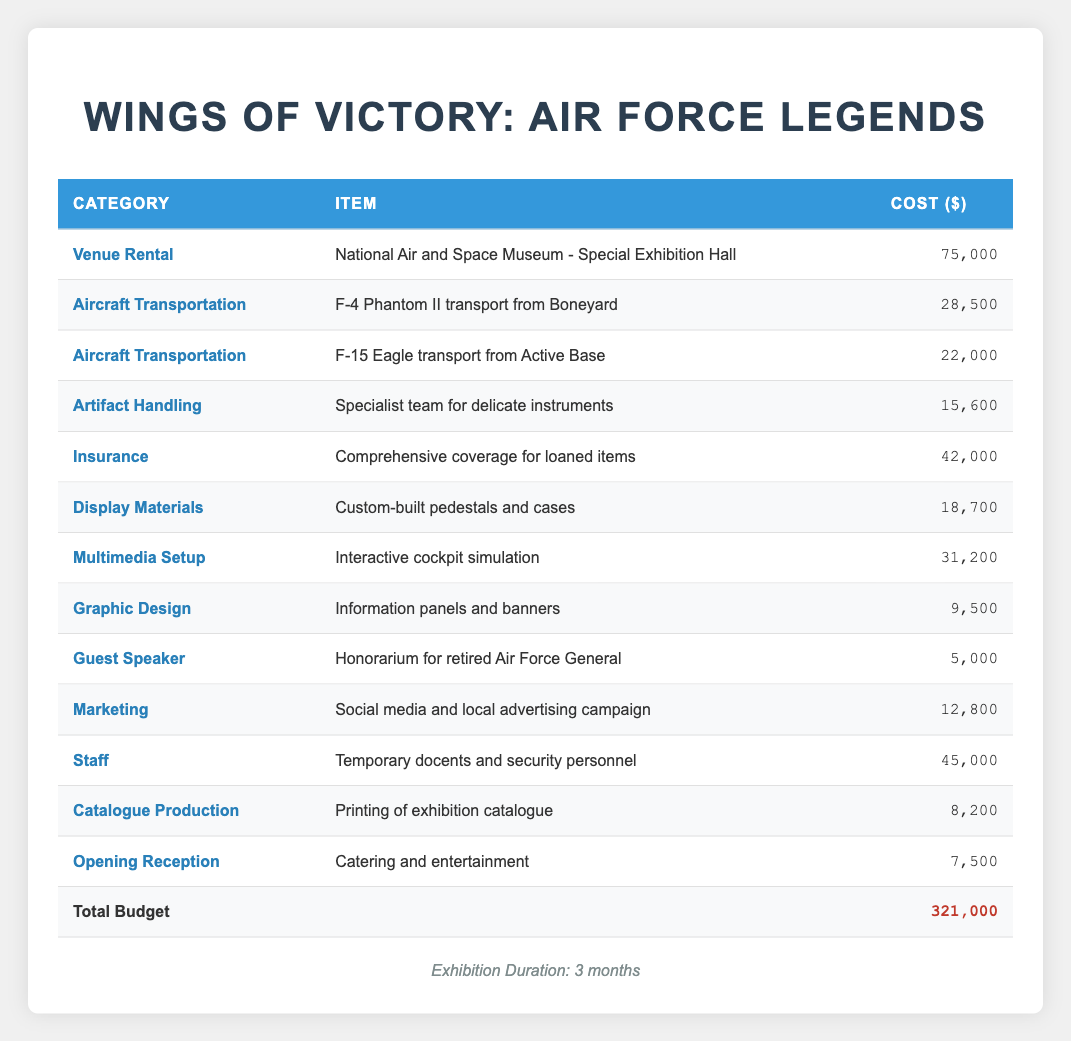What's the total cost for Insurance? The cost for Insurance is explicitly listed in the table as 42,000.
Answer: 42,000 What is the sum of the expenses for Aircraft Transportation? The expenses under Aircraft Transportation are for "F-4 Phantom II transport from Boneyard" costing 28,500 and "F-15 Eagle transport from Active Base" costing 22,000. Adding these amounts gives 28,500 + 22,000 = 50,500.
Answer: 50,500 Is the cost for Graphic Design less than the cost for Catalogue Production? The cost for Graphic Design is 9,500 and the cost for Catalogue Production is 8,200. Since 9,500 is greater than 8,200, the statement is false.
Answer: No What is the difference between the highest and lowest expenses listed? The highest expense is Venue Rental at 75,000, and the lowest is Guest Speaker at 5,000. To find the difference, subtract the lowest from the highest: 75,000 - 5,000 = 70,000.
Answer: 70,000 How much of the total budget is allocated to Display Materials compared to Staff? The cost for Display Materials is 18,700 and for Staff is 45,000. Adding both gives 18,700 + 45,000 = 63,700. Then, to find the percentage of the total budget of 321,000 that this represents: (63,700 / 321,000) * 100 = approximately 19.83%.
Answer: Approximately 19.83% What is the average cost of the items within the Artifact Handling and Insurance categories? The cost for Artifact Handling is 15,600 and for Insurance is 42,000. Adding these amounts gives 15,600 + 42,000 = 57,600. There are 2 items, so the average cost is 57,600 / 2 = 28,800.
Answer: 28,800 Does the expense for the Opening Reception exceed the sum of the expenses for the Graphic Design and Catalogue Production categories? The Opening Reception costs 7,500. The Graphic Design costs 9,500 and Catalogue Production costs 8,200, giving a total of 9,500 + 8,200 = 17,700. Since 7,500 is less than 17,700, the statement is false.
Answer: No Calculate the total cost for all marketing-related expenses. The marketing-related expense consists of the Marketing campaign costing 12,800. There are no other marketing-related items in the table, so the total cost remains 12,800.
Answer: 12,800 